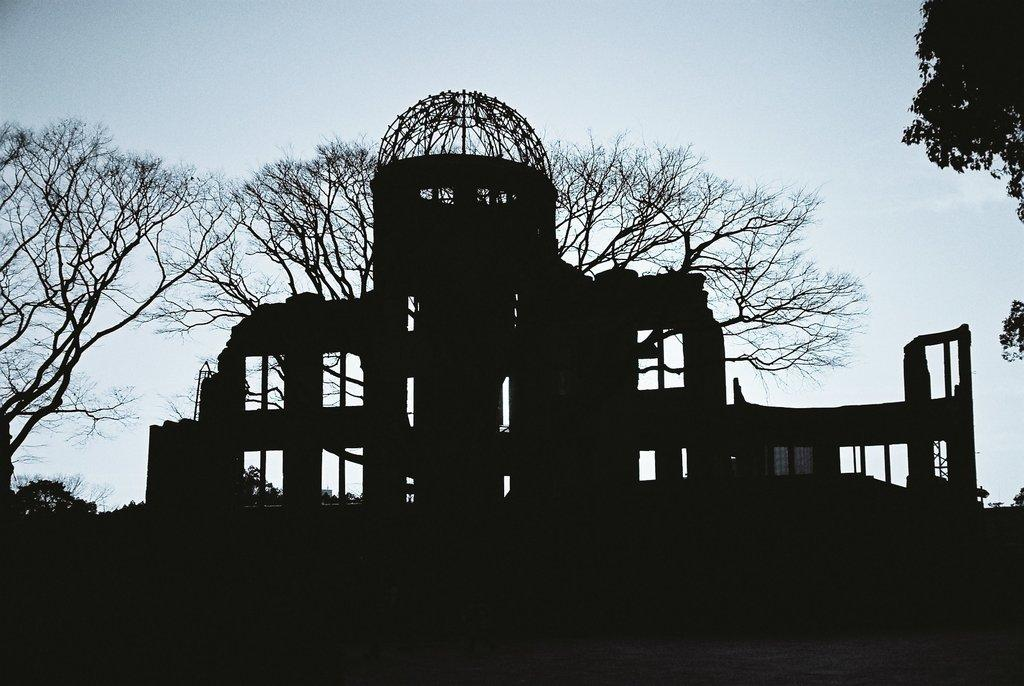What is the color scheme of the image? The image is black and white. What type of structure can be seen in the image? There is a building in the image. What other elements are present in the image besides the building? There are trees, windows, and the sky visible in the image. What flavor of ice cream is being served by the authority figure in the image? There is no ice cream or authority figure present in the image. What type of spark can be seen coming from the trees in the image? There is no spark visible in the image; the trees are not on fire or displaying any unusual activity. 